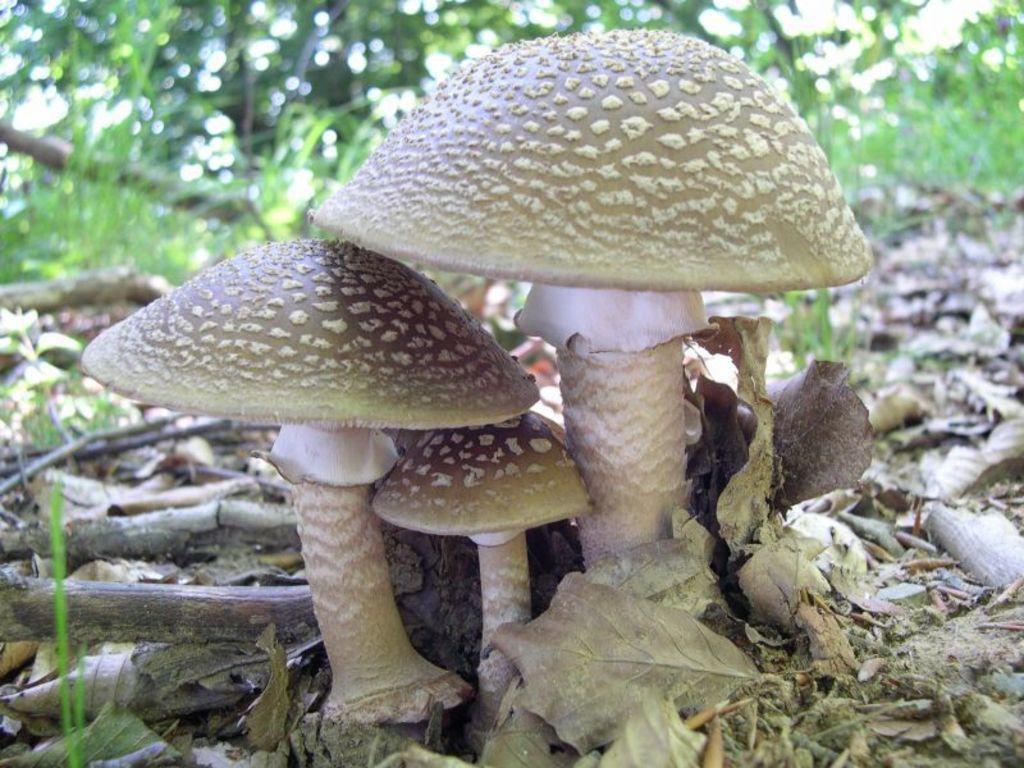Please provide a concise description of this image. In the center of the image we can see mushrooms, sticks and dry leaves. In the background, we can see trees, grass and a few other objects. 